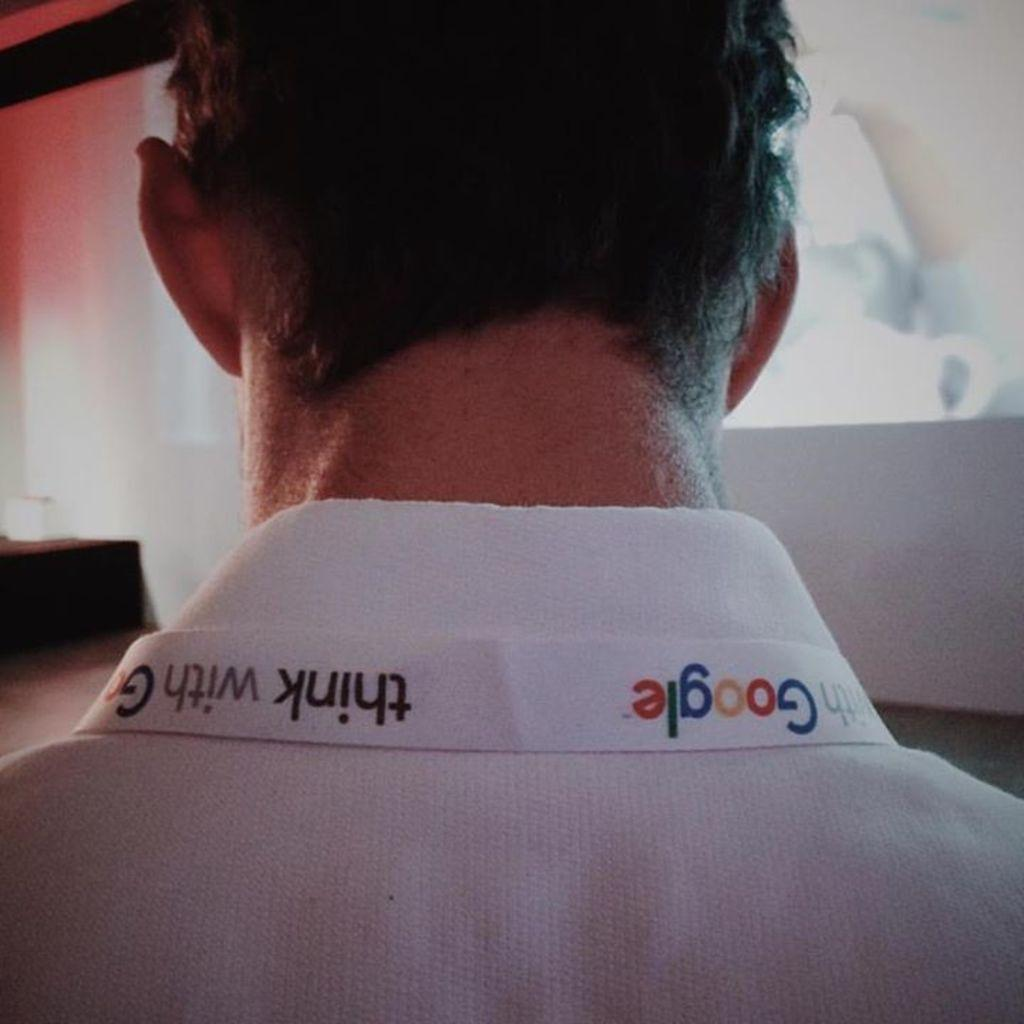What is present in the image? There is a person in the image. What part of the person's body can be seen? The person's neck and head are visible. What is the person wearing? The person is wearing a white color shirt. Is there any text on the shirt? Yes, there is text visible on the shirt. What type of art can be seen on the island in the image? There is no island or art present in the image; it features a person with a shirt that has text on it. 